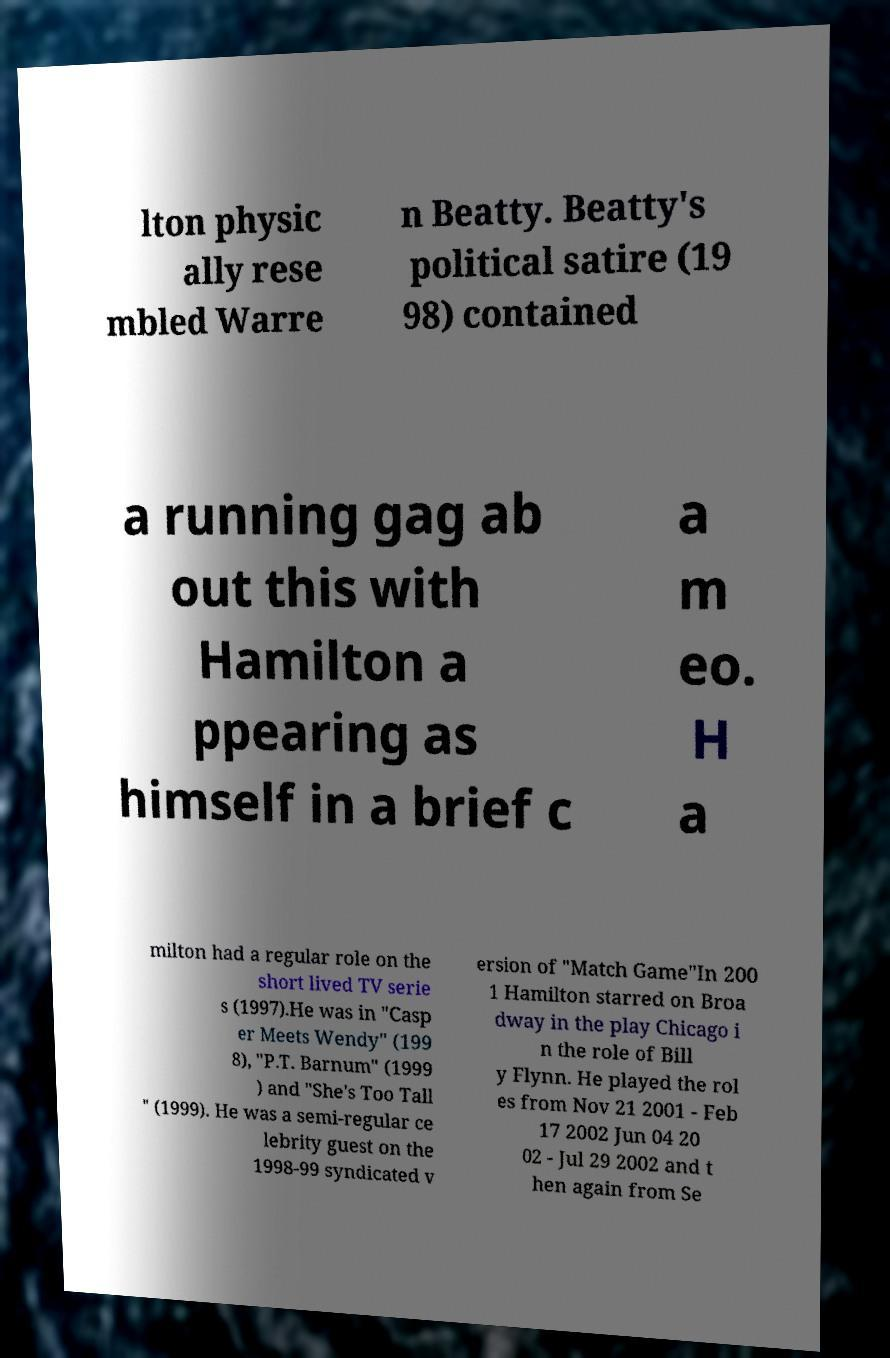Could you extract and type out the text from this image? lton physic ally rese mbled Warre n Beatty. Beatty's political satire (19 98) contained a running gag ab out this with Hamilton a ppearing as himself in a brief c a m eo. H a milton had a regular role on the short lived TV serie s (1997).He was in "Casp er Meets Wendy" (199 8), "P.T. Barnum" (1999 ) and "She's Too Tall " (1999). He was a semi-regular ce lebrity guest on the 1998-99 syndicated v ersion of "Match Game"In 200 1 Hamilton starred on Broa dway in the play Chicago i n the role of Bill y Flynn. He played the rol es from Nov 21 2001 - Feb 17 2002 Jun 04 20 02 - Jul 29 2002 and t hen again from Se 